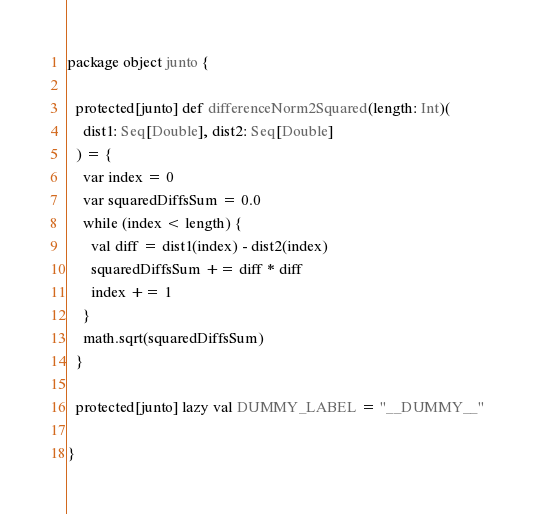Convert code to text. <code><loc_0><loc_0><loc_500><loc_500><_Scala_>package object junto {

  protected[junto] def differenceNorm2Squared(length: Int)(
    dist1: Seq[Double], dist2: Seq[Double]
  ) = {
    var index = 0
    var squaredDiffsSum = 0.0
    while (index < length) {
      val diff = dist1(index) - dist2(index)
      squaredDiffsSum += diff * diff
      index += 1
    }
    math.sqrt(squaredDiffsSum)
  }

  protected[junto] lazy val DUMMY_LABEL = "__DUMMY__"

}
</code> 